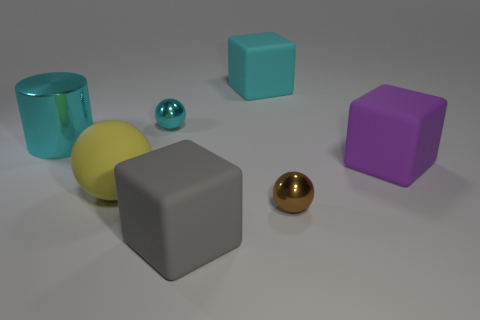Subtract 1 blocks. How many blocks are left? 2 Add 2 gray rubber cubes. How many objects exist? 9 Subtract all cylinders. How many objects are left? 6 Subtract 0 purple cylinders. How many objects are left? 7 Subtract all cylinders. Subtract all purple rubber blocks. How many objects are left? 5 Add 2 tiny things. How many tiny things are left? 4 Add 5 small gray shiny balls. How many small gray shiny balls exist? 5 